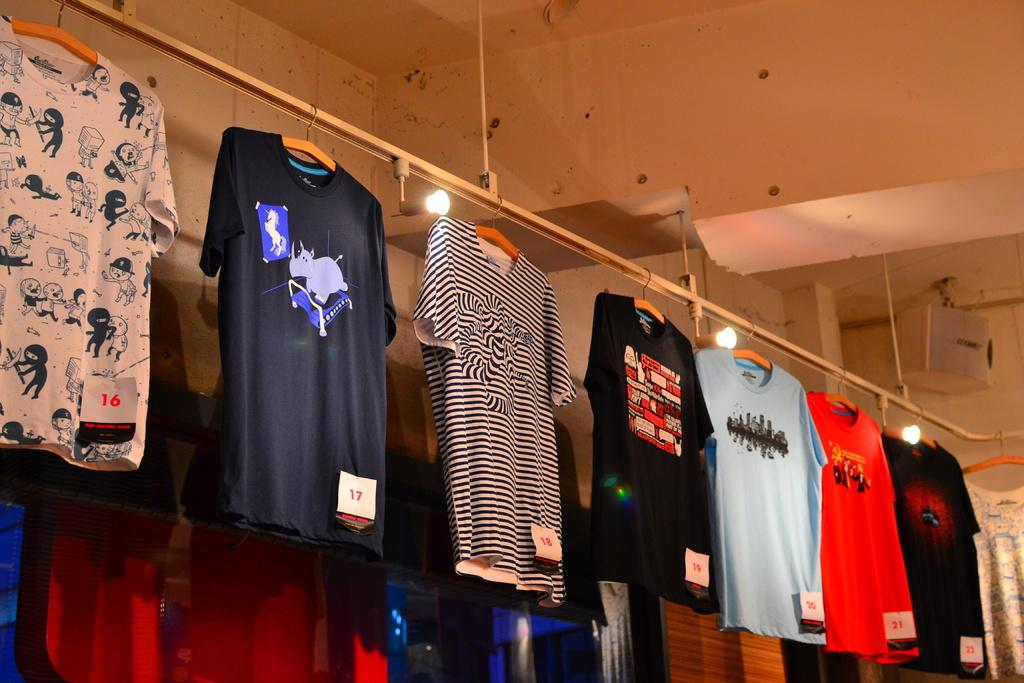What type of clothing can be seen in the front of the image? There are t-shirts in the front of the image. What is visible in the background of the image? There is a wall and three lights in the background of the image. Are there any stockings visible in the image? There is no mention of stockings in the provided facts, so we cannot determine if they are present in the image. 